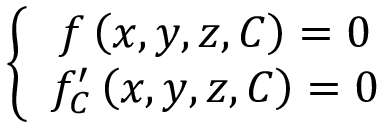Convert formula to latex. <formula><loc_0><loc_0><loc_500><loc_500>\left \{ \begin{array} { c } { f \left ( x , y , z , C \right ) = 0 } \\ { f _ { C } ^ { \prime } \left ( x , y , z , C \right ) = 0 } \end{array}</formula> 